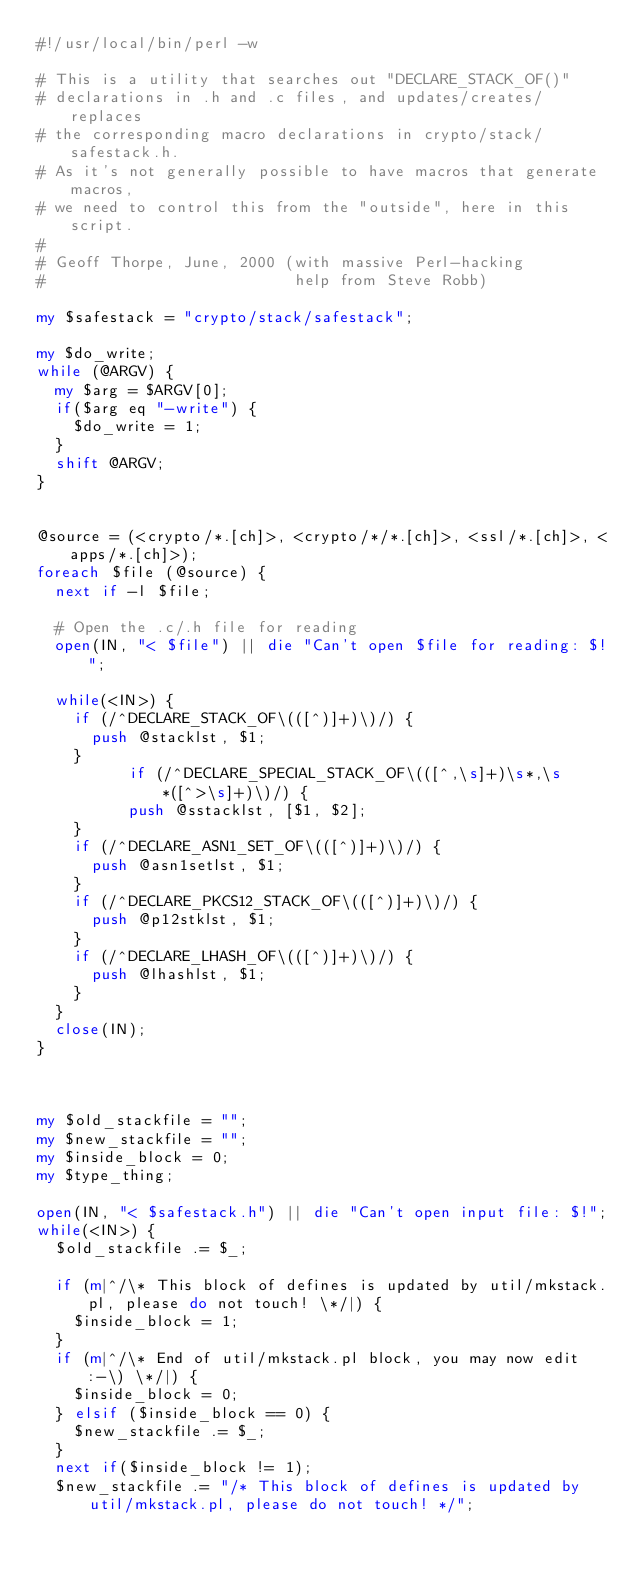Convert code to text. <code><loc_0><loc_0><loc_500><loc_500><_Perl_>#!/usr/local/bin/perl -w

# This is a utility that searches out "DECLARE_STACK_OF()"
# declarations in .h and .c files, and updates/creates/replaces
# the corresponding macro declarations in crypto/stack/safestack.h.
# As it's not generally possible to have macros that generate macros,
# we need to control this from the "outside", here in this script.
#
# Geoff Thorpe, June, 2000 (with massive Perl-hacking
#                           help from Steve Robb)

my $safestack = "crypto/stack/safestack";

my $do_write;
while (@ARGV) {
	my $arg = $ARGV[0];
	if($arg eq "-write") {
		$do_write = 1;
	}
	shift @ARGV;
}


@source = (<crypto/*.[ch]>, <crypto/*/*.[ch]>, <ssl/*.[ch]>, <apps/*.[ch]>);
foreach $file (@source) {
	next if -l $file;

	# Open the .c/.h file for reading
	open(IN, "< $file") || die "Can't open $file for reading: $!";

	while(<IN>) {
		if (/^DECLARE_STACK_OF\(([^)]+)\)/) {
			push @stacklst, $1;
		}
	        if (/^DECLARE_SPECIAL_STACK_OF\(([^,\s]+)\s*,\s*([^>\s]+)\)/) {
		    	push @sstacklst, [$1, $2];
		}
		if (/^DECLARE_ASN1_SET_OF\(([^)]+)\)/) {
			push @asn1setlst, $1;
		}
		if (/^DECLARE_PKCS12_STACK_OF\(([^)]+)\)/) {
			push @p12stklst, $1;
		}
		if (/^DECLARE_LHASH_OF\(([^)]+)\)/) {
			push @lhashlst, $1;
		}
	}
	close(IN);
}



my $old_stackfile = "";
my $new_stackfile = "";
my $inside_block = 0;
my $type_thing;

open(IN, "< $safestack.h") || die "Can't open input file: $!";
while(<IN>) {
	$old_stackfile .= $_;

	if (m|^/\* This block of defines is updated by util/mkstack.pl, please do not touch! \*/|) {
		$inside_block = 1;
	}
	if (m|^/\* End of util/mkstack.pl block, you may now edit :-\) \*/|) {
		$inside_block = 0;
	} elsif ($inside_block == 0) {
		$new_stackfile .= $_;
	}
	next if($inside_block != 1);
	$new_stackfile .= "/* This block of defines is updated by util/mkstack.pl, please do not touch! */";
		</code> 